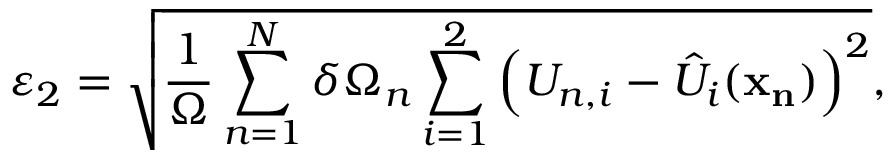Convert formula to latex. <formula><loc_0><loc_0><loc_500><loc_500>\varepsilon _ { 2 } = \sqrt { \frac { 1 } { \Omega } \sum _ { n = 1 } ^ { N } \delta \Omega _ { n } \sum _ { i = 1 } ^ { 2 } \left ( U _ { n , i } - \hat { U } _ { i } ( x _ { n } ) \right ) ^ { 2 } } ,</formula> 